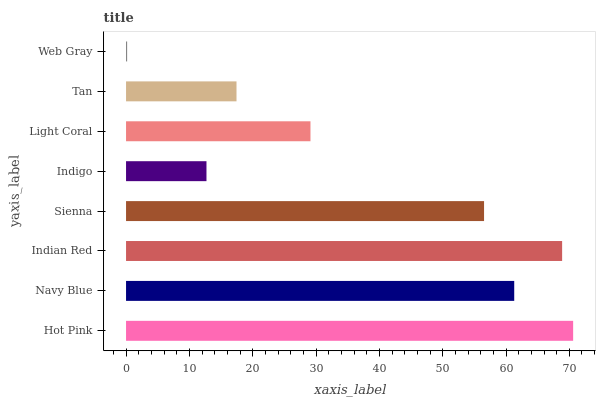Is Web Gray the minimum?
Answer yes or no. Yes. Is Hot Pink the maximum?
Answer yes or no. Yes. Is Navy Blue the minimum?
Answer yes or no. No. Is Navy Blue the maximum?
Answer yes or no. No. Is Hot Pink greater than Navy Blue?
Answer yes or no. Yes. Is Navy Blue less than Hot Pink?
Answer yes or no. Yes. Is Navy Blue greater than Hot Pink?
Answer yes or no. No. Is Hot Pink less than Navy Blue?
Answer yes or no. No. Is Sienna the high median?
Answer yes or no. Yes. Is Light Coral the low median?
Answer yes or no. Yes. Is Hot Pink the high median?
Answer yes or no. No. Is Sienna the low median?
Answer yes or no. No. 